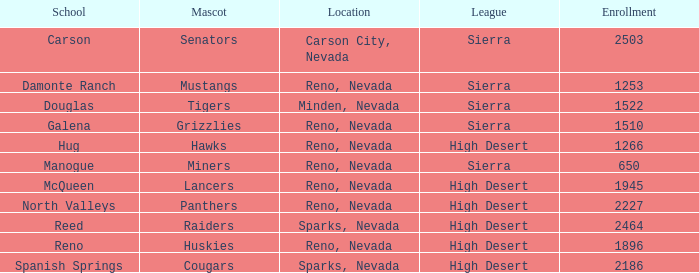Which school has the Raiders as their mascot? Reed. 